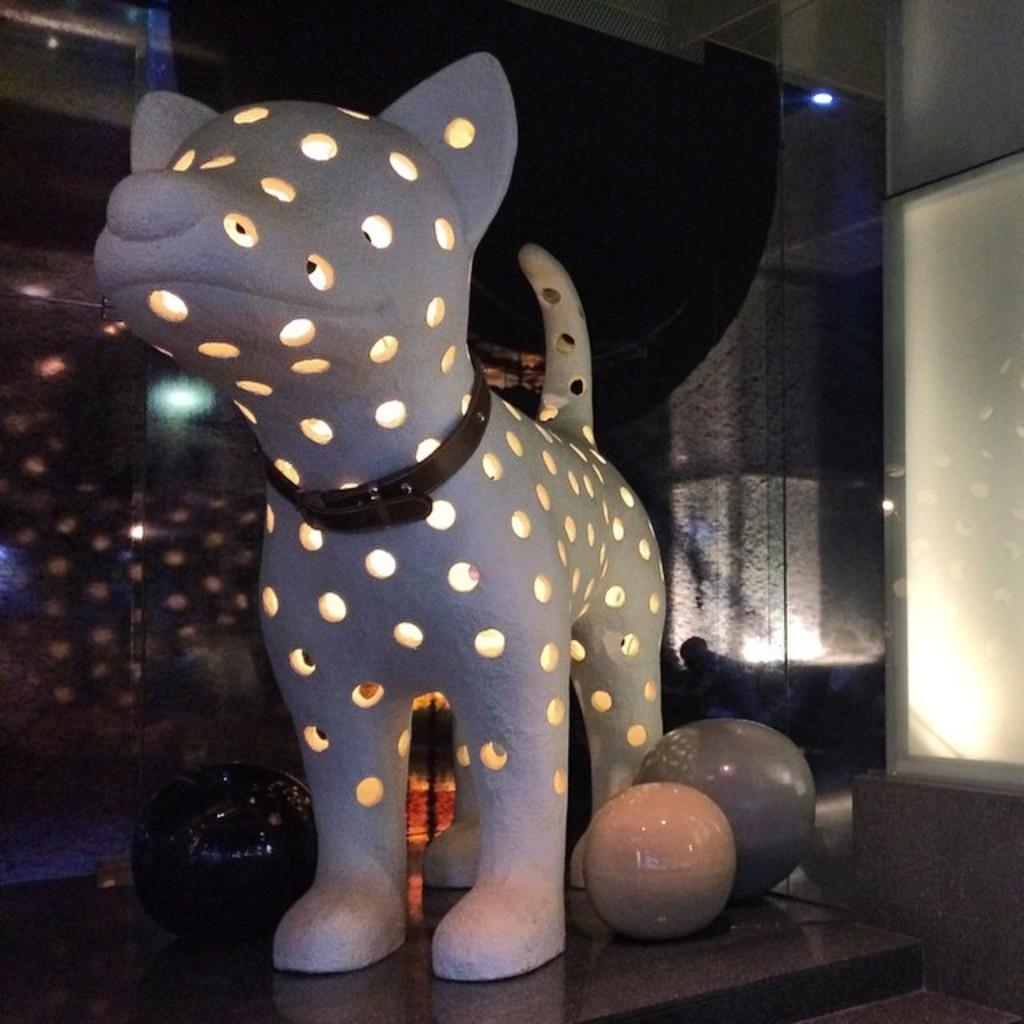What is on the floor in the image? There is a dog's structure on the floor in the image. What can be seen inside the dog's structure? There are holes in the dog's structure, and light is visible inside them. What is behind the dog's structure? There is a wall behind the dog's structure. What is on the wall? There is a light on the wall. What example of a dog's mind can be seen in the image? There is no representation of a dog's mind in the image; it only shows a dog's structure on the floor. 